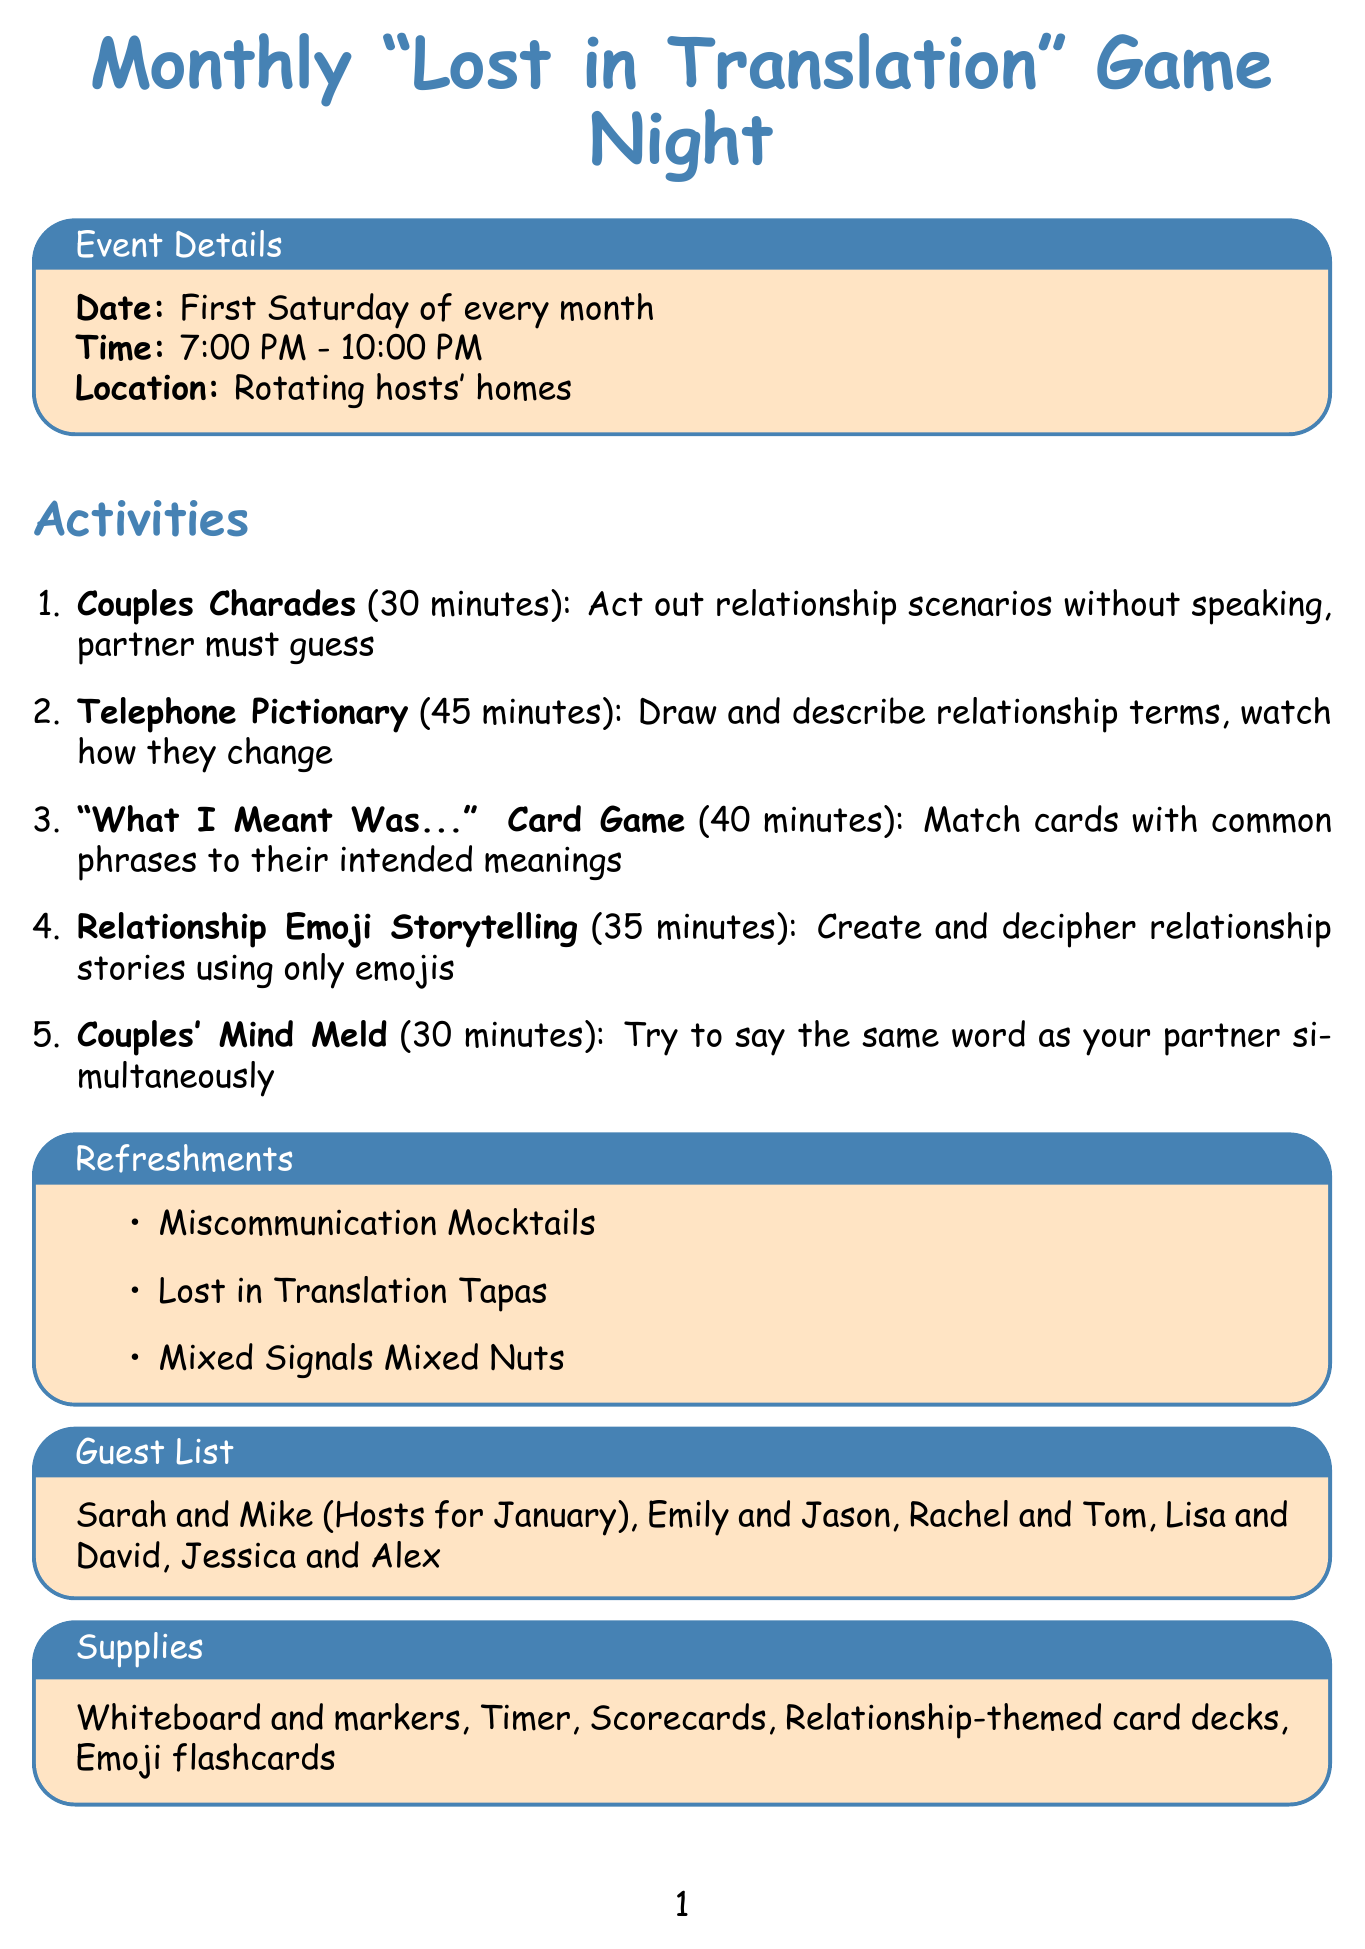what is the event name? The event name is specified at the beginning of the document as part of the title.
Answer: Monthly 'Lost in Translation' Game Night when does the game night occur? The document outlines the recurring date for the event clearly in the event details section.
Answer: First Saturday of every month how long does Couples Charades last? The duration of each activity is provided in the activities section, specifically for Couples Charades.
Answer: 30 minutes what is the location of the event? The location is mentioned in the event details section.
Answer: Rotating hosts' homes who are the hosts for January? The guest list section contains the names of the hosts for January.
Answer: Sarah and Mike which activity involves emojis? By reading the activities section, one can identify which activity pertains to emojis.
Answer: Relationship Emoji Storytelling name one refreshment item. The refreshment items are listed under a dedicated section; any one of them can be provided as an answer.
Answer: Miscommunication Mocktails how long is the discussion on the funniest miscommunication? This topic is part of the discussion topics, which do not state durations; hence it requires inference about the discussion length.
Answer: N/A what is a prize offered? The prizes section lists various prizes that can be won during the game night.
Answer: Couple's Communication 101 Book 